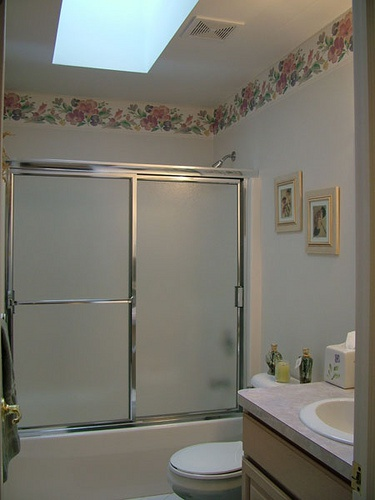Describe the objects in this image and their specific colors. I can see toilet in black, darkgray, and gray tones, sink in black, darkgray, and gray tones, and bottle in black, gray, and darkgreen tones in this image. 